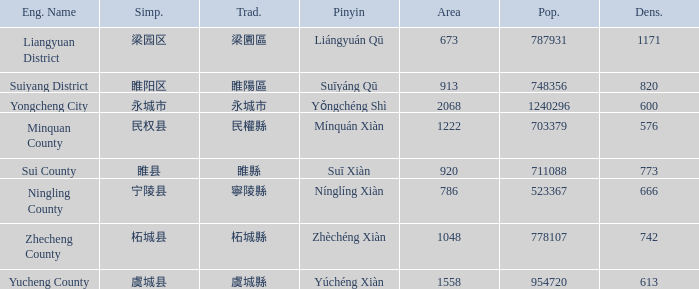How many figures are there for density for Yucheng County? 1.0. 